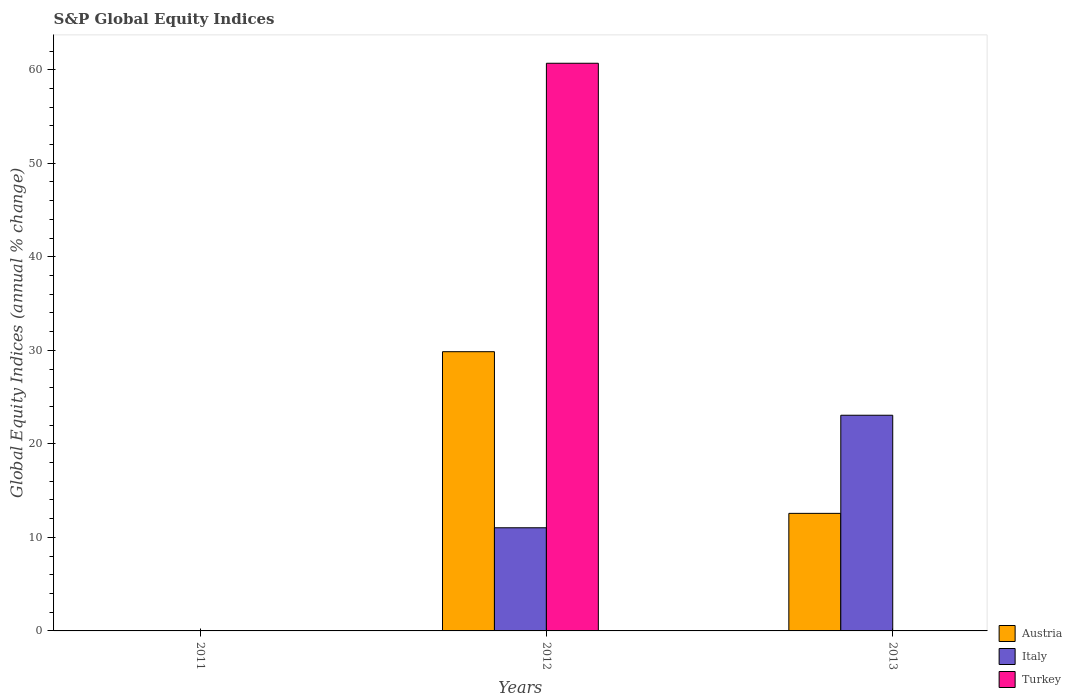Are the number of bars per tick equal to the number of legend labels?
Provide a succinct answer. No. How many bars are there on the 1st tick from the right?
Ensure brevity in your answer.  2. What is the label of the 3rd group of bars from the left?
Give a very brief answer. 2013. In how many cases, is the number of bars for a given year not equal to the number of legend labels?
Your answer should be compact. 2. What is the global equity indices in Italy in 2012?
Keep it short and to the point. 11.03. Across all years, what is the maximum global equity indices in Italy?
Offer a very short reply. 23.06. Across all years, what is the minimum global equity indices in Austria?
Your answer should be compact. 0. What is the total global equity indices in Turkey in the graph?
Your response must be concise. 60.69. What is the difference between the global equity indices in Italy in 2012 and that in 2013?
Provide a short and direct response. -12.03. What is the difference between the global equity indices in Austria in 2011 and the global equity indices in Italy in 2012?
Keep it short and to the point. -11.03. What is the average global equity indices in Italy per year?
Offer a very short reply. 11.36. In the year 2012, what is the difference between the global equity indices in Italy and global equity indices in Austria?
Give a very brief answer. -18.82. In how many years, is the global equity indices in Turkey greater than 26 %?
Give a very brief answer. 1. What is the ratio of the global equity indices in Italy in 2012 to that in 2013?
Offer a terse response. 0.48. Is the difference between the global equity indices in Italy in 2012 and 2013 greater than the difference between the global equity indices in Austria in 2012 and 2013?
Keep it short and to the point. No. What is the difference between the highest and the lowest global equity indices in Italy?
Provide a succinct answer. 23.06. How many bars are there?
Offer a terse response. 5. What is the difference between two consecutive major ticks on the Y-axis?
Your response must be concise. 10. Does the graph contain any zero values?
Make the answer very short. Yes. Where does the legend appear in the graph?
Give a very brief answer. Bottom right. What is the title of the graph?
Offer a terse response. S&P Global Equity Indices. What is the label or title of the X-axis?
Offer a terse response. Years. What is the label or title of the Y-axis?
Provide a succinct answer. Global Equity Indices (annual % change). What is the Global Equity Indices (annual % change) in Italy in 2011?
Ensure brevity in your answer.  0. What is the Global Equity Indices (annual % change) of Austria in 2012?
Offer a very short reply. 29.85. What is the Global Equity Indices (annual % change) in Italy in 2012?
Your response must be concise. 11.03. What is the Global Equity Indices (annual % change) of Turkey in 2012?
Provide a short and direct response. 60.69. What is the Global Equity Indices (annual % change) of Austria in 2013?
Provide a short and direct response. 12.57. What is the Global Equity Indices (annual % change) in Italy in 2013?
Your response must be concise. 23.06. What is the Global Equity Indices (annual % change) of Turkey in 2013?
Keep it short and to the point. 0. Across all years, what is the maximum Global Equity Indices (annual % change) in Austria?
Provide a short and direct response. 29.85. Across all years, what is the maximum Global Equity Indices (annual % change) of Italy?
Give a very brief answer. 23.06. Across all years, what is the maximum Global Equity Indices (annual % change) in Turkey?
Keep it short and to the point. 60.69. Across all years, what is the minimum Global Equity Indices (annual % change) of Austria?
Your answer should be compact. 0. Across all years, what is the minimum Global Equity Indices (annual % change) of Italy?
Your answer should be compact. 0. Across all years, what is the minimum Global Equity Indices (annual % change) of Turkey?
Make the answer very short. 0. What is the total Global Equity Indices (annual % change) in Austria in the graph?
Give a very brief answer. 42.42. What is the total Global Equity Indices (annual % change) of Italy in the graph?
Provide a succinct answer. 34.09. What is the total Global Equity Indices (annual % change) of Turkey in the graph?
Your answer should be compact. 60.69. What is the difference between the Global Equity Indices (annual % change) in Austria in 2012 and that in 2013?
Provide a succinct answer. 17.28. What is the difference between the Global Equity Indices (annual % change) in Italy in 2012 and that in 2013?
Keep it short and to the point. -12.03. What is the difference between the Global Equity Indices (annual % change) in Austria in 2012 and the Global Equity Indices (annual % change) in Italy in 2013?
Ensure brevity in your answer.  6.79. What is the average Global Equity Indices (annual % change) of Austria per year?
Your answer should be compact. 14.14. What is the average Global Equity Indices (annual % change) in Italy per year?
Your answer should be compact. 11.36. What is the average Global Equity Indices (annual % change) of Turkey per year?
Make the answer very short. 20.23. In the year 2012, what is the difference between the Global Equity Indices (annual % change) of Austria and Global Equity Indices (annual % change) of Italy?
Make the answer very short. 18.82. In the year 2012, what is the difference between the Global Equity Indices (annual % change) of Austria and Global Equity Indices (annual % change) of Turkey?
Ensure brevity in your answer.  -30.84. In the year 2012, what is the difference between the Global Equity Indices (annual % change) in Italy and Global Equity Indices (annual % change) in Turkey?
Give a very brief answer. -49.66. In the year 2013, what is the difference between the Global Equity Indices (annual % change) of Austria and Global Equity Indices (annual % change) of Italy?
Make the answer very short. -10.49. What is the ratio of the Global Equity Indices (annual % change) of Austria in 2012 to that in 2013?
Your response must be concise. 2.38. What is the ratio of the Global Equity Indices (annual % change) in Italy in 2012 to that in 2013?
Make the answer very short. 0.48. What is the difference between the highest and the lowest Global Equity Indices (annual % change) in Austria?
Provide a short and direct response. 29.85. What is the difference between the highest and the lowest Global Equity Indices (annual % change) of Italy?
Your response must be concise. 23.06. What is the difference between the highest and the lowest Global Equity Indices (annual % change) in Turkey?
Your answer should be compact. 60.69. 